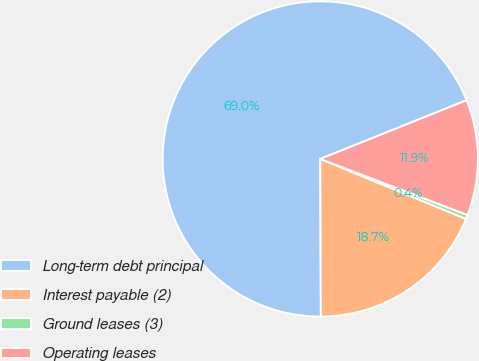Convert chart to OTSL. <chart><loc_0><loc_0><loc_500><loc_500><pie_chart><fcel>Long-term debt principal<fcel>Interest payable (2)<fcel>Ground leases (3)<fcel>Operating leases<nl><fcel>68.98%<fcel>18.72%<fcel>0.43%<fcel>11.86%<nl></chart> 